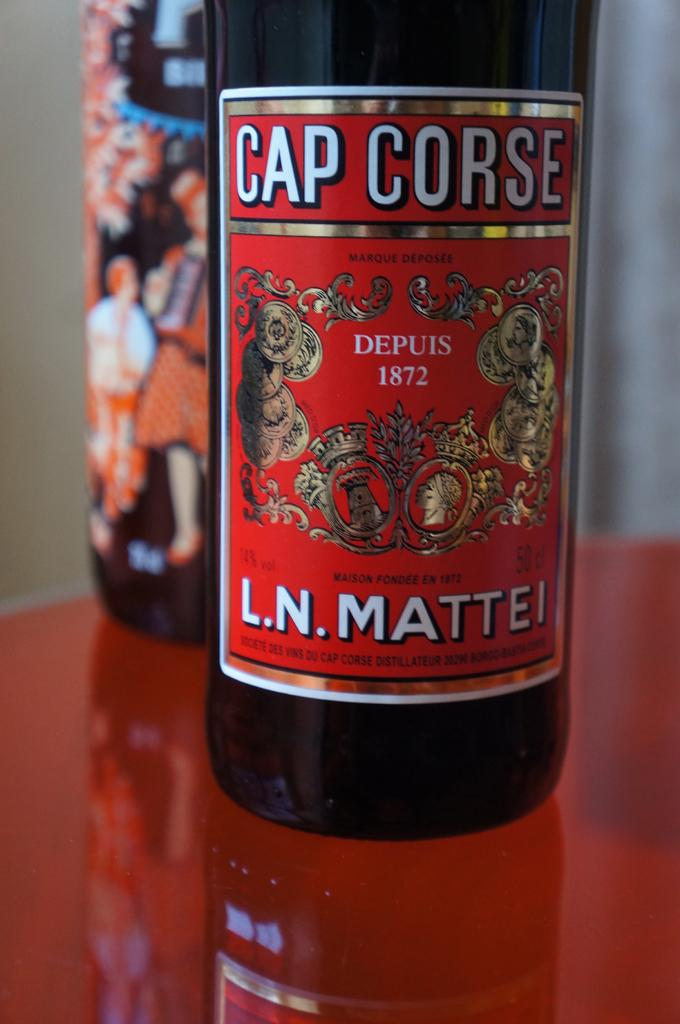<image>
Present a compact description of the photo's key features. a bottle of CAP CORSE L.N. MATTEI LIQUOR. 